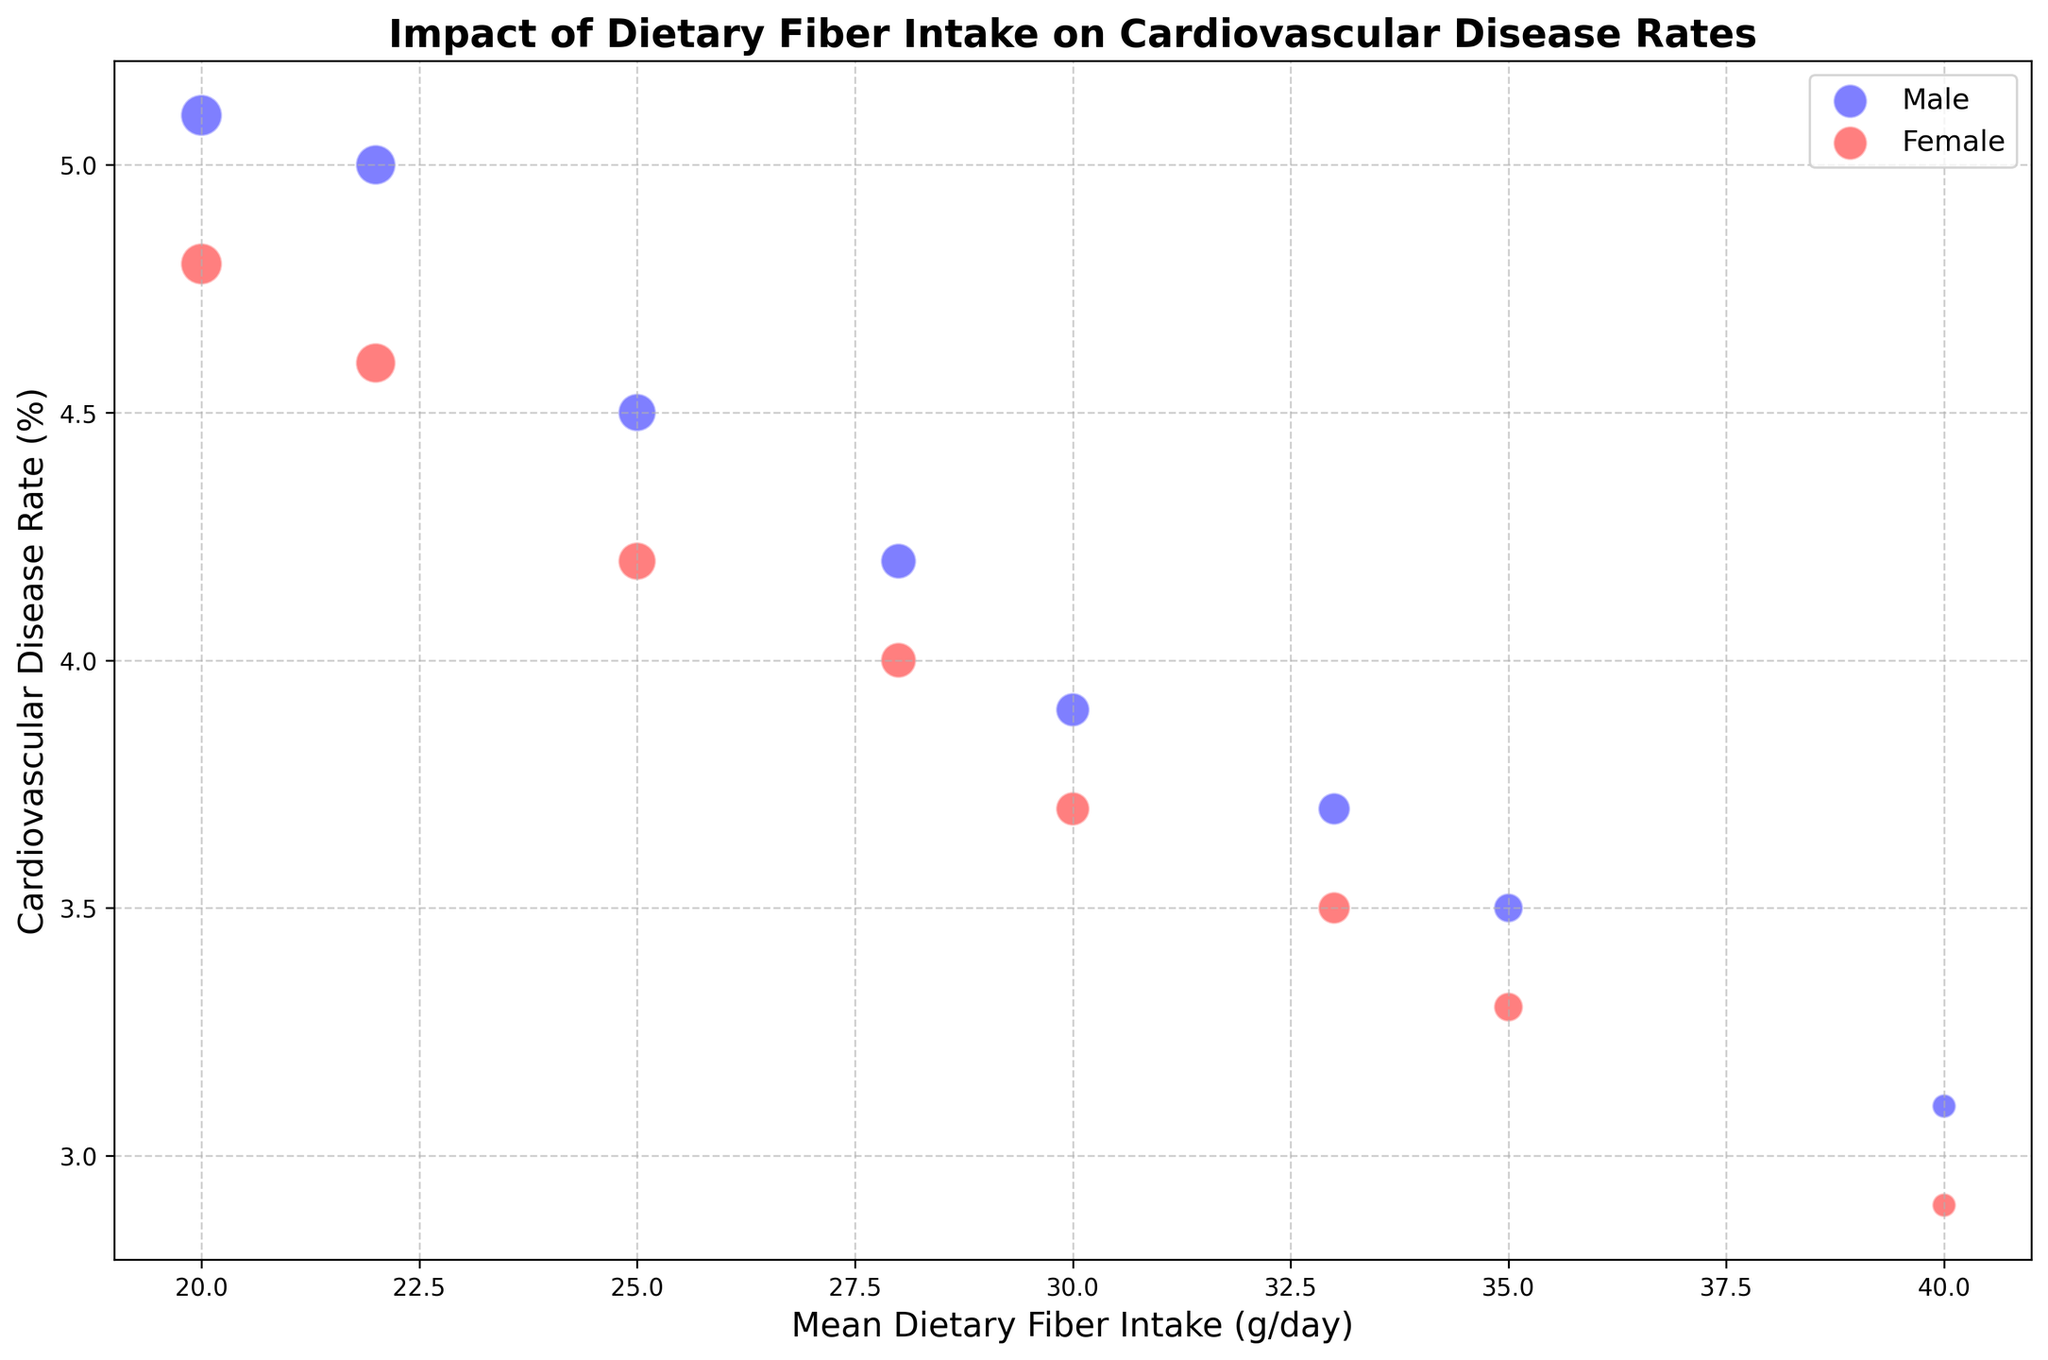What is the relationship between dietary fiber intake and cardiovascular disease rates for males? As the mean dietary fiber intake increases, the cardiovascular disease rate decreases for males. For example, at 20 g/day, the rate is 5.1%, and at 40 g/day, it drops to 3.1%.
Answer: Cardiovascular disease rates decrease with higher dietary fiber intake What is the difference in cardiovascular disease rates between males and females at 30 g/day of dietary fiber intake? For males, the cardiovascular disease rate at 30 g/day is 3.9%. For females, it is 3.7%. The difference can be calculated as 3.9% - 3.7%.
Answer: 0.2% Which gender has a lower obesity rate at 25 g/day dietary fiber intake? For males, the obesity rate at 25 g/day is 20%. For females, it is 18%. Since 18% is lower than 20%, females have a lower obesity rate at this level of dietary fiber intake.
Answer: Females What is the average cardiovascular disease rate for males with dietary fiber intake of 20 g, 25 g, and 30 g/day? The cardiovascular disease rates for males at 20 g, 25 g, and 30 g/day are 5.1%, 4.5%, and 3.9%, respectively. Average = (5.1 + 4.5 + 3.9) / 3 = 4.5%.
Answer: 4.5% Among males and females, who shows a larger reduction in cardiovascular disease rate from 20 g/day to 40 g/day of dietary fiber intake? For males, the reduction from 20 g/day (5.1%) to 40 g/day (3.1%) is 5.1% - 3.1% = 2%. For females, the reduction from 20 g/day (4.8%) to 40 g/day (2.9%) is 4.8% - 2.9% = 1.9%. Therefore, males show a larger reduction.
Answer: Males At 35 g/day dietary fiber intake, which gender has a larger bubble size, and what does this indicate? At 35 g/day dietary fiber intake, both males and females have bubble sizes of 150. This indicates that the represented population size for both genders is the same at this dietary fiber intake level.
Answer: Both have equal bubble sizes How does the bubble size change with dietary fiber intake for males? For males, the bubble size decreases as dietary fiber intake increases. The bubble sizes are 300, 280, 250, 220, 200, 180, 150, 100 for increasing fiber intakes.
Answer: It decreases What is the cardiovascular disease rate at the lowest bubble size for females? The lowest bubble size for females is 100, which corresponds to a dietary fiber intake of 40 g/day. The cardiovascular disease rate at this intake level is 2.9%.
Answer: 2.9% Between 20 g/day and 30 g/day of dietary fiber intake, which gender shows a steeper decline in cardiovascular disease rates? For males, the decline from 20 g/day (5.1%) to 30 g/day (3.9%) is 1.2%. For females, the decline from 20 g/day (4.8%) to 30 g/day (3.7%) is 1.1%. Therefore, males show a steeper decline.
Answer: Males 